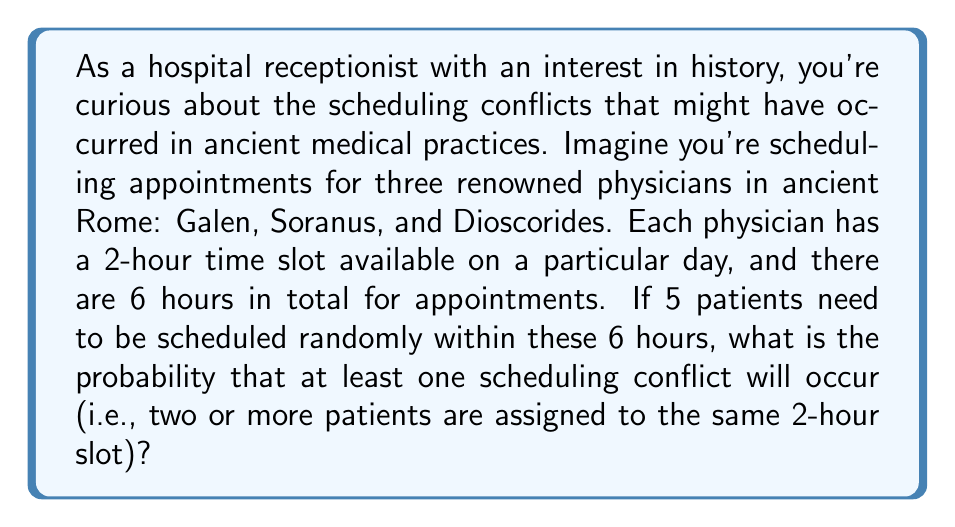Could you help me with this problem? Let's approach this step-by-step:

1) First, we need to calculate the total number of ways to distribute 5 patients among 3 time slots. This is a classic "stars and bars" problem, where we have $n = 5$ items (patients) and $k = 3$ bins (time slots). The formula for this is:

   $${n+k-1 \choose k-1} = {5+3-1 \choose 3-1} = {7 \choose 2} = 21$$

2) Now, we need to calculate the number of ways to distribute the patients without any conflicts. This is equivalent to distributing 5 patients among 3 time slots with at most 2 patients per slot. We can use the principle of inclusion-exclusion:

   - Ways to have 3 or more in the first slot: ${5 \choose 3}{2 \choose 2} = 10$
   - Ways to have 3 or more in the second slot: ${5 \choose 3}{2 \choose 2} = 10$
   - Ways to have 3 or more in the third slot: ${5 \choose 3}{2 \choose 2} = 10$
   - Ways to have 3 or more in two slots: $0$ (impossible with 5 patients)

   Total = $21 - (10 + 10 + 10) + 0 = -9$

3) However, this negative number doesn't make sense in our context. The issue is that we've double-counted some cases. Let's count the valid distributions directly:

   $(2,2,1)$: ${5 \choose 2}{3 \choose 2} = 10 \cdot 3 = 30$ ways
   $(2,1,2)$: ${5 \choose 2}{3 \choose 2} = 10 \cdot 3 = 30$ ways
   $(1,2,2)$: ${5 \choose 2}{3 \choose 2} = 10 \cdot 3 = 30$ ways

   Total valid distributions: $30 + 30 + 30 = 90$

4) Now we can calculate the probability of at least one conflict:

   $$P(\text{at least one conflict}) = 1 - P(\text{no conflicts})$$
   $$= 1 - \frac{\text{number of ways without conflicts}}{\text{total number of ways}}$$
   $$= 1 - \frac{90}{21^5}$$
   $$= 1 - \frac{90}{4084101}$$
   $$\approx 0.99998$$
Answer: $1 - \frac{90}{4084101} \approx 0.99998$ 